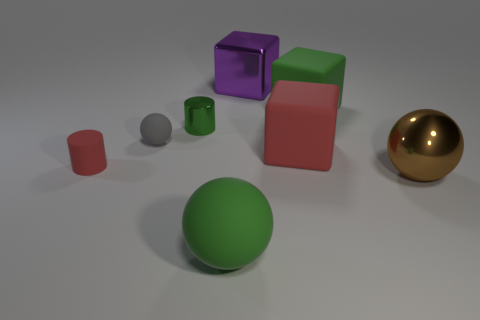Add 1 large blue cubes. How many objects exist? 9 Subtract all cylinders. How many objects are left? 6 Subtract 0 brown blocks. How many objects are left? 8 Subtract all matte objects. Subtract all brown matte balls. How many objects are left? 3 Add 8 large red things. How many large red things are left? 9 Add 2 small red rubber objects. How many small red rubber objects exist? 3 